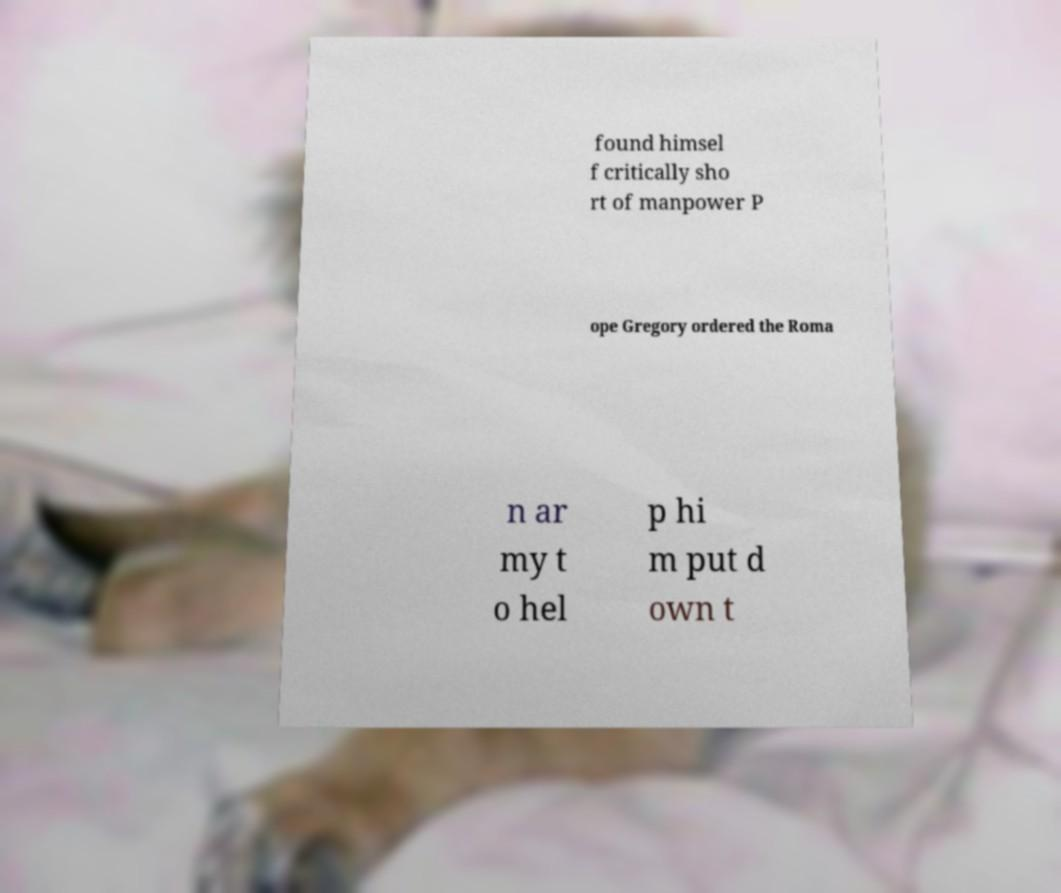Could you assist in decoding the text presented in this image and type it out clearly? found himsel f critically sho rt of manpower P ope Gregory ordered the Roma n ar my t o hel p hi m put d own t 